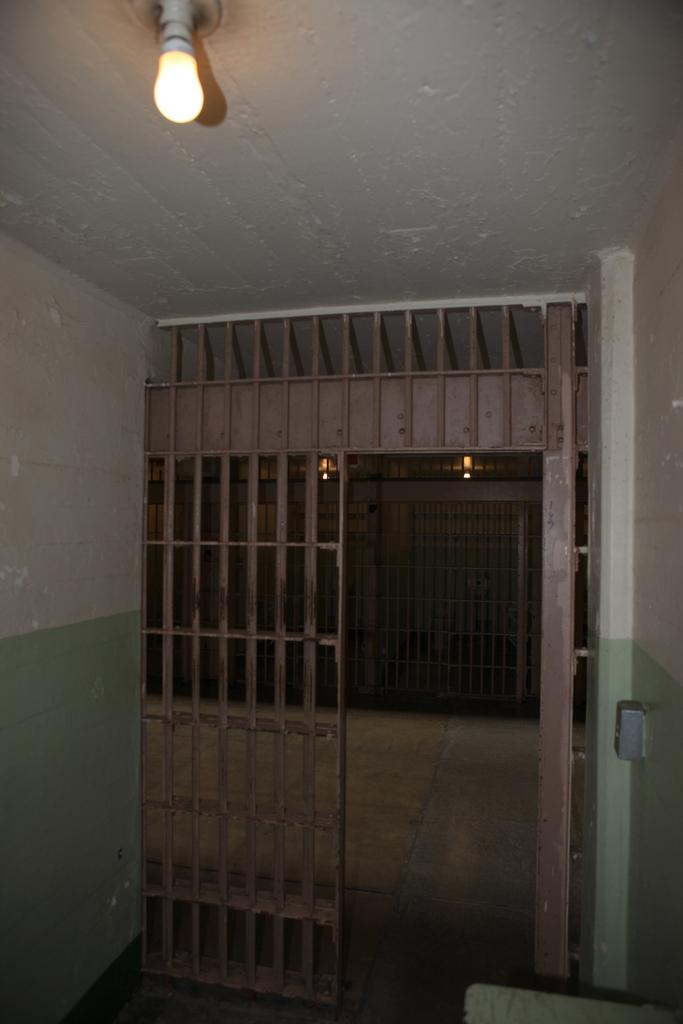What is the main object in the image? There is a grill in the image. What type of structures are present in the image? There are walls in the image. What can be seen on the ground in the image? There is a path in the image. What provides illumination in the image? There are lights in the image. What is above the grill in the image? There is a ceiling in the image. What type of plate is being used to serve the food on the grill? There is no plate visible in the image; the food is being cooked directly on the grill. 